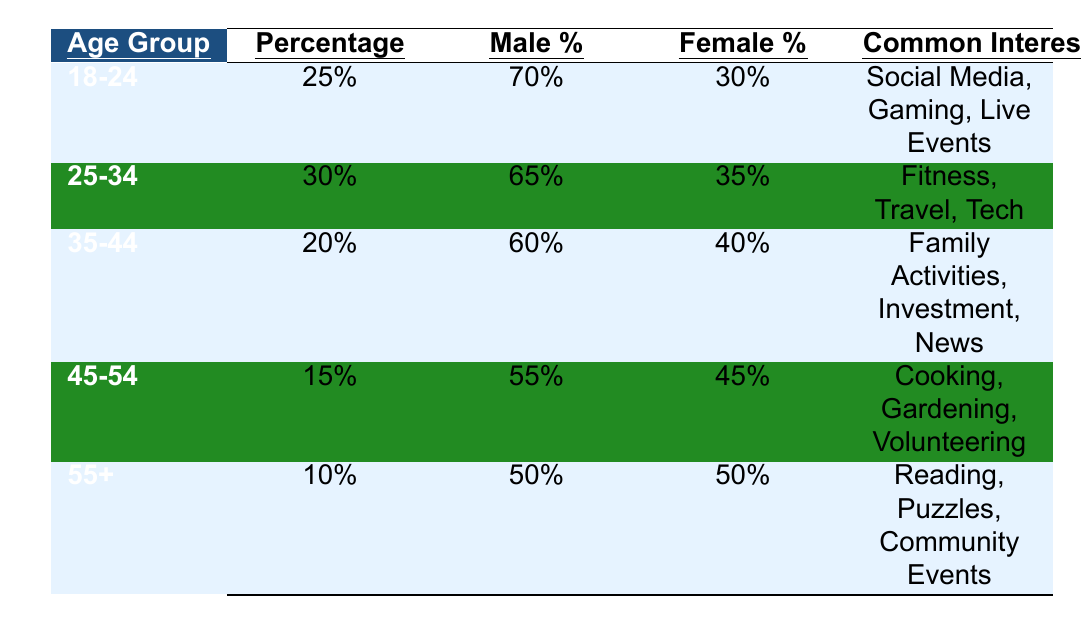What is the percentage of listeners in the age group 25-34? The table indicates that the percentage of listeners in the age group 25-34 is listed under the "Percentage" column next to this age group, which shows 30%.
Answer: 30% Which age group has the highest percentage of listeners? The age groups and their respective percentages are compared. The age group 25-34 has the highest percentage at 30%, while the 18-24 group follows with 25%.
Answer: 25-34 What is the male percentage of listeners in the age group 45-54? The data for the age group 45-54 reveals that the male percentage is stated under the "Male %" column, which shows 55%.
Answer: 55% Is the common interest for the 35-44 age group related to fitness? Looking at the "Common Interests" for the 35-44 age group, it lists Family Activities, Investment, and News. Fitness is not mentioned, thus the statement is false.
Answer: No What is the difference between the male percentages of listeners in the age groups 18-24 and 55+? The male percentage for 18-24 is 70%, and for 55+, it is 50%. The difference is calculated as 70% - 50% = 20%.
Answer: 20% What age group has the closest male to female percentage balance? The male and female percentages for the 55+ age group both equal 50%, indicating a perfect balance. This is compared to the other groups, which do not have this balance.
Answer: 55+ What is the sum of the percentages of all age groups? The percentages from the table are added up: 25% + 30% + 20% + 15% + 10% = 100%.
Answer: 100% What are the common interests of listeners aged 45-54? Referring to the "Common Interests" column for the age group 45-54 shows Cooking, Gardening, and Volunteering as the main interests.
Answer: Cooking, Gardening, Volunteering How many age groups have a male percentage above 60%? The table reveals that the 18-24 (70%), 25-34 (65%), and 35-44 (60%) age groups all have male percentages above 60%, amounting to three groups.
Answer: 3 Which age group has the highest female percentage? Observing the female percentages, the age group 45-54 has the highest female percentage at 45%, compared to others which are lower.
Answer: 45-54 